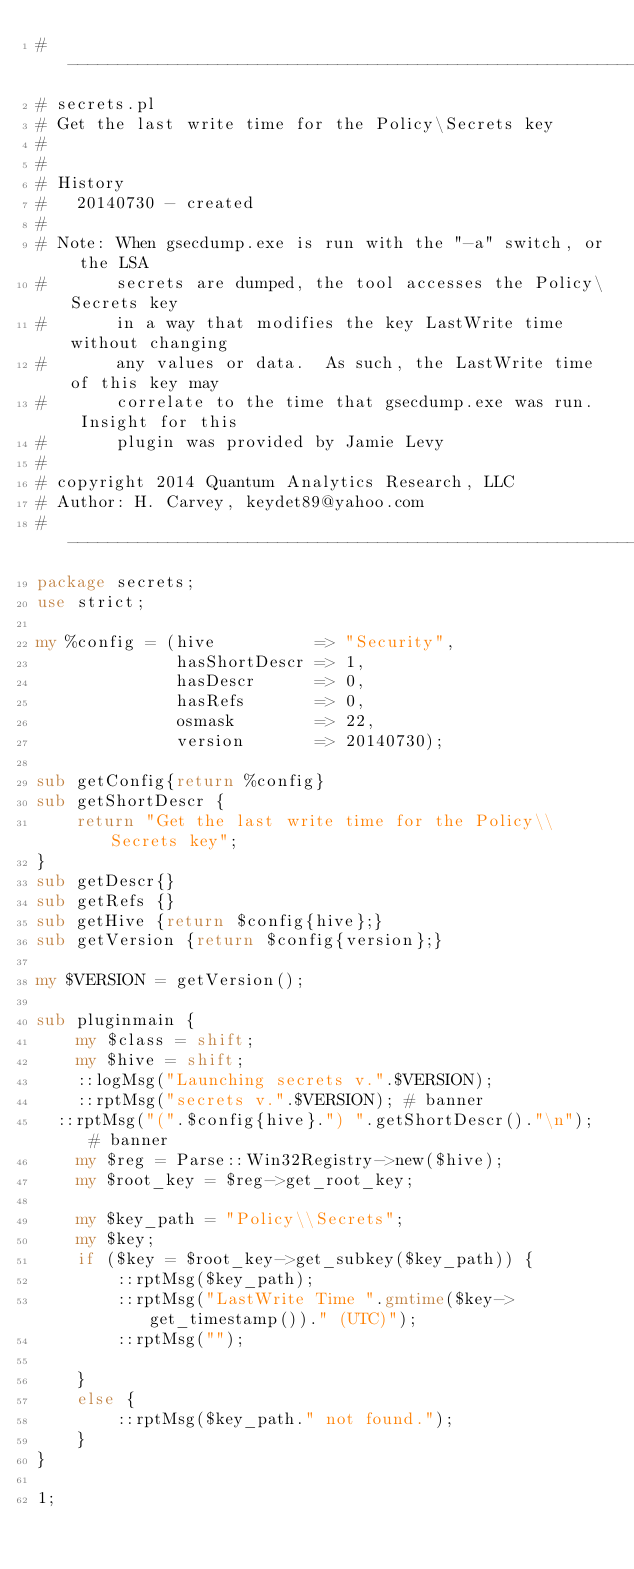<code> <loc_0><loc_0><loc_500><loc_500><_Perl_>#-----------------------------------------------------------
# secrets.pl
# Get the last write time for the Policy\Secrets key
# 
#
# History
#   20140730 - created
#
# Note: When gsecdump.exe is run with the "-a" switch, or the LSA
#       secrets are dumped, the tool accesses the Policy\Secrets key
#       in a way that modifies the key LastWrite time without changing
#       any values or data.  As such, the LastWrite time of this key may
#       correlate to the time that gsecdump.exe was run.  Insight for this
#       plugin was provided by Jamie Levy
#
# copyright 2014 Quantum Analytics Research, LLC
# Author: H. Carvey, keydet89@yahoo.com
#-----------------------------------------------------------
package secrets;
use strict;

my %config = (hive          => "Security",
              hasShortDescr => 1,
              hasDescr      => 0,
              hasRefs       => 0,
              osmask        => 22,
              version       => 20140730);

sub getConfig{return %config}
sub getShortDescr {
	return "Get the last write time for the Policy\\Secrets key";	
}
sub getDescr{}
sub getRefs {}
sub getHive {return $config{hive};}
sub getVersion {return $config{version};}

my $VERSION = getVersion();

sub pluginmain {
	my $class = shift;
	my $hive = shift;
	::logMsg("Launching secrets v.".$VERSION);
	::rptMsg("secrets v.".$VERSION); # banner
  ::rptMsg("(".$config{hive}.") ".getShortDescr()."\n"); # banner
	my $reg = Parse::Win32Registry->new($hive);
	my $root_key = $reg->get_root_key;

	my $key_path = "Policy\\Secrets";
	my $key;
	if ($key = $root_key->get_subkey($key_path)) {
		::rptMsg($key_path);
		::rptMsg("LastWrite Time ".gmtime($key->get_timestamp())." (UTC)");
		::rptMsg("");

	}
	else {
		::rptMsg($key_path." not found.");
	}
}

1;</code> 